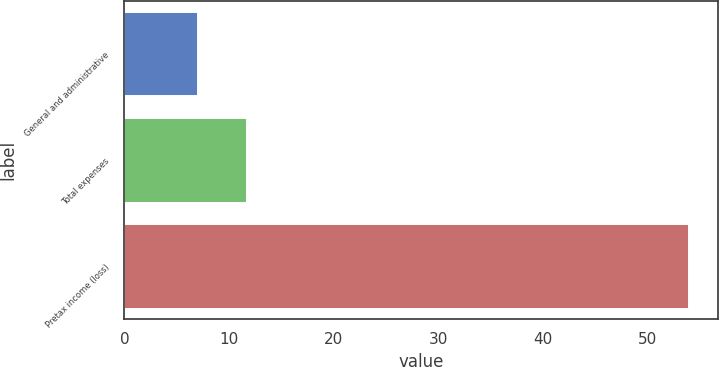Convert chart to OTSL. <chart><loc_0><loc_0><loc_500><loc_500><bar_chart><fcel>General and administrative<fcel>Total expenses<fcel>Pretax income (loss)<nl><fcel>7<fcel>11.7<fcel>54<nl></chart> 